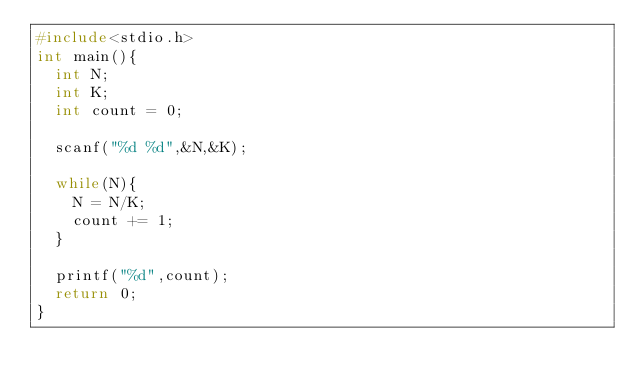Convert code to text. <code><loc_0><loc_0><loc_500><loc_500><_C_>#include<stdio.h>
int main(){
  int N;
  int K;
  int count = 0;
  
  scanf("%d %d",&N,&K);

  while(N){
    N = N/K;
    count += 1;
  }

  printf("%d",count);
  return 0;
}
</code> 